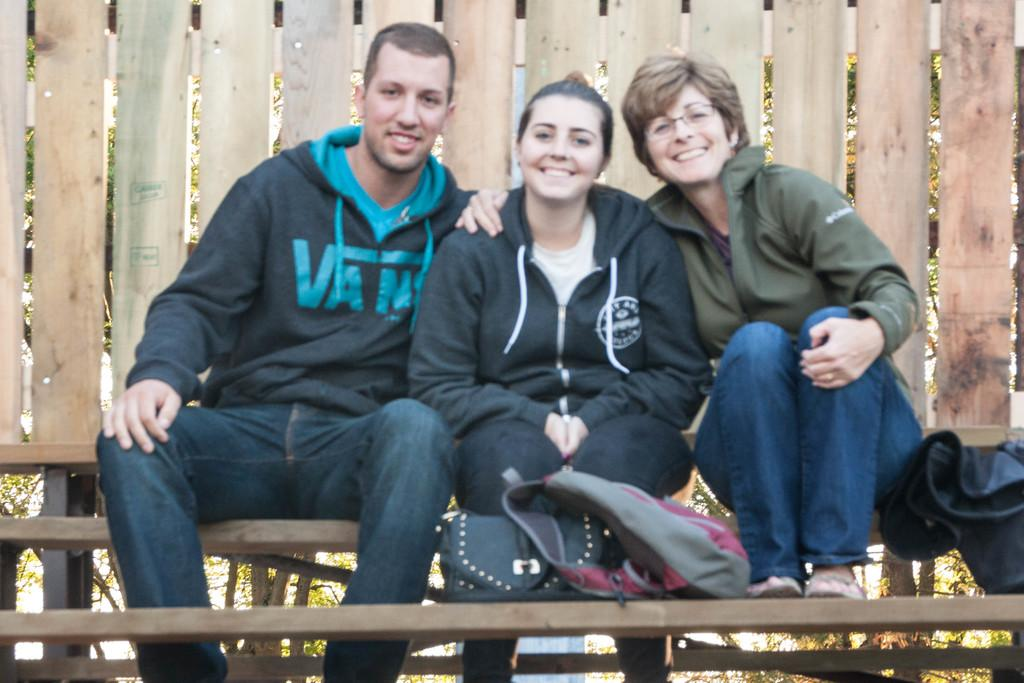How many people are sitting on the bench in the image? There are three people sitting on the bench in the image. What is the facial expression of the people in the image? The people are smiling in the image. What objects are placed near the bench? There are bags placed nearby. What can be seen in the background of the image? There is a wooden fencing and trees visible in the background. What type of sheet is being used for arithmetic calculations in the image? There is no sheet or arithmetic calculations present in the image. Is there a boot visible on the bench in the image? No, there is no boot visible on the bench in the image. 